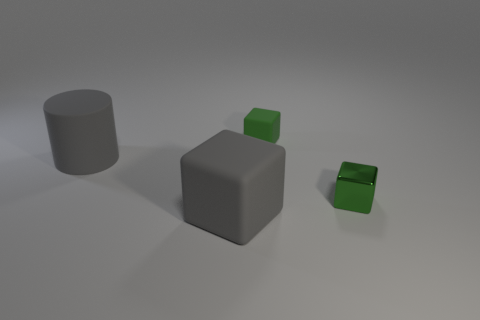Subtract all rubber blocks. How many blocks are left? 1 Subtract all yellow spheres. How many green cubes are left? 2 Add 1 small blue matte blocks. How many objects exist? 5 Subtract all blocks. How many objects are left? 1 Subtract 2 blocks. How many blocks are left? 1 Subtract all cyan cubes. Subtract all yellow cylinders. How many cubes are left? 3 Add 2 tiny purple rubber objects. How many tiny purple rubber objects exist? 2 Subtract 0 red cylinders. How many objects are left? 4 Subtract all tiny green cubes. Subtract all big gray rubber cylinders. How many objects are left? 1 Add 3 big matte blocks. How many big matte blocks are left? 4 